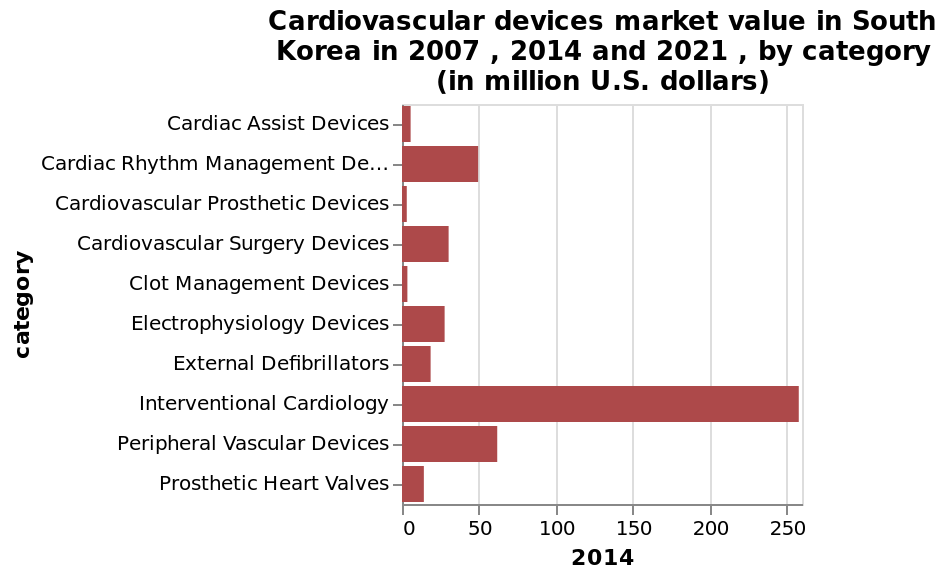<image>
please summary the statistics and relations of the chart Interventional Cardiology is by far the highest market value of all the devices in South Korea. This is almost 5x as popular as the second highest, Peripheral Vascular Devices in 2014. The graph has a title for 2007, 2014 and 2021, but only shows the statistics for 2014. What are the years mentioned in the bar chart?  The years mentioned in the bar chart are 2007, 2014, and 2021. 